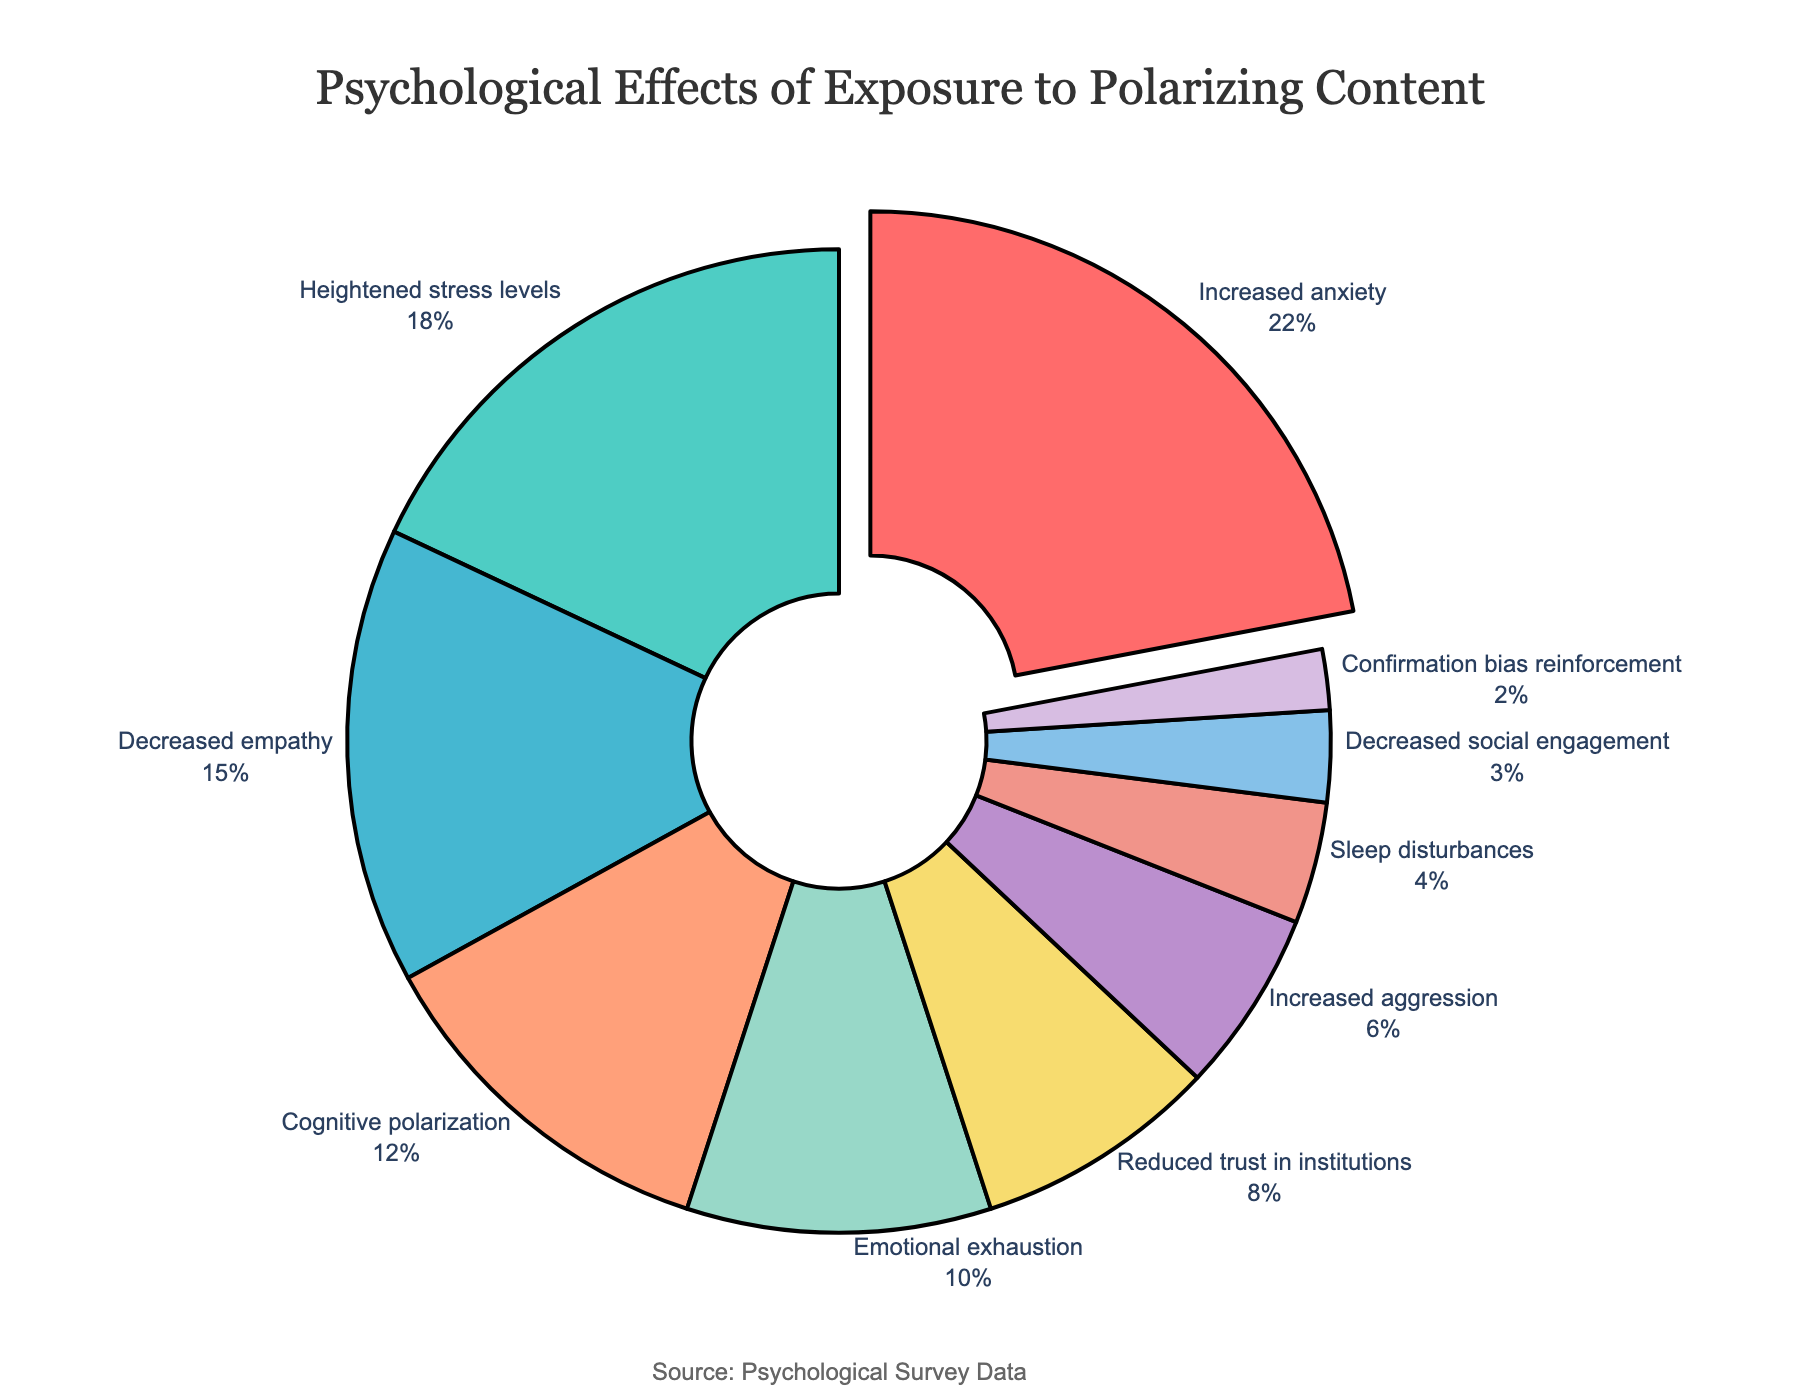What is the most common psychological effect of exposure to polarizing content? The figure shows the pie chart with different symptoms and their respective percentages. The largest segment with a percentage of 22% corresponds to "Increased anxiety," indicating it is the most common effect.
Answer: Increased anxiety What percentage of psychological effects is attributed to "Decreased empathy" and "Cognitive polarization" combined? The pie chart indicates that "Decreased empathy" is 15% and "Cognitive polarization" is 12%. Adding these together results in 15% + 12% = 27%.
Answer: 27% Which symptom has a higher prevalence: "Heightened stress levels" or "Reduced trust in institutions"? Comparing the segments for these two symptoms in the pie chart, "Heightened stress levels" is 18%, whereas "Reduced trust in institutions" is 8%. Therefore, "Heightened stress levels" has a higher prevalence.
Answer: Heightened stress levels Is "Emotional exhaustion" more or less prevalent than "Increased aggression"? Referring to the pie chart, "Emotional exhaustion" has a percentage of 10%, while "Increased aggression" has a percentage of 6%. Therefore, "Emotional exhaustion" is more prevalent than "Increased aggression."
Answer: More prevalent Which color represents "Sleep disturbances" in the pie chart? By examining the colors and their corresponding labels in the pie chart, the segment labeled "Sleep disturbances" is marked in a light pinkish color.
Answer: Light pinkish What is the total percentage of symptoms that are related to aggression or stress (including "Heightened stress levels" and "Increased aggression")? The pie chart shows "Heightened stress levels" at 18% and "Increased aggression" at 6%. Adding these together results in 18% + 6% = 24%.
Answer: 24% Compare the percentages of "Decreased social engagement" and "Confirmation bias reinforcement." Which one is higher and by how much? According to the pie chart, "Decreased social engagement" is 3% and "Confirmation bias reinforcement" is 2%. The difference is 3% - 2% = 1%. Hence, "Decreased social engagement" is higher by 1%.
Answer: Decreased social engagement by 1% What fraction of the pie chart is represented by "Increased anxiety"? The pie chart illustrates that "Increased anxiety" holds 22% of the total. Since percentages are out of 100, the fraction is 22/100, which simplifies to 11/50.
Answer: 11/50 How does the prevalence of "Reduced trust in institutions" compare to "Sleep disturbances"? According to the pie chart, "Reduced trust in institutions" is 8%, whereas "Sleep disturbances" is 4%. Therefore, "Reduced trust in institutions" is double the prevalence of "Sleep disturbances."
Answer: Double What is the combined percentage of less common symptoms (those under 10%)? The less common symptoms are "Increased aggression" (6%), "Sleep disturbances" (4%), "Decreased social engagement" (3%), and "Confirmation bias reinforcement" (2%). Adding these together gives 6% + 4% + 3% + 2% = 15%.
Answer: 15% 